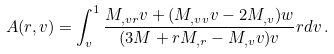<formula> <loc_0><loc_0><loc_500><loc_500>A ( r , v ) = \int _ { v } ^ { 1 } \frac { M _ { , v r } v + ( M _ { , v v } v - 2 M _ { , v } ) w } { ( 3 M + r M _ { , r } - M _ { , v } v ) v } r d v \, .</formula> 